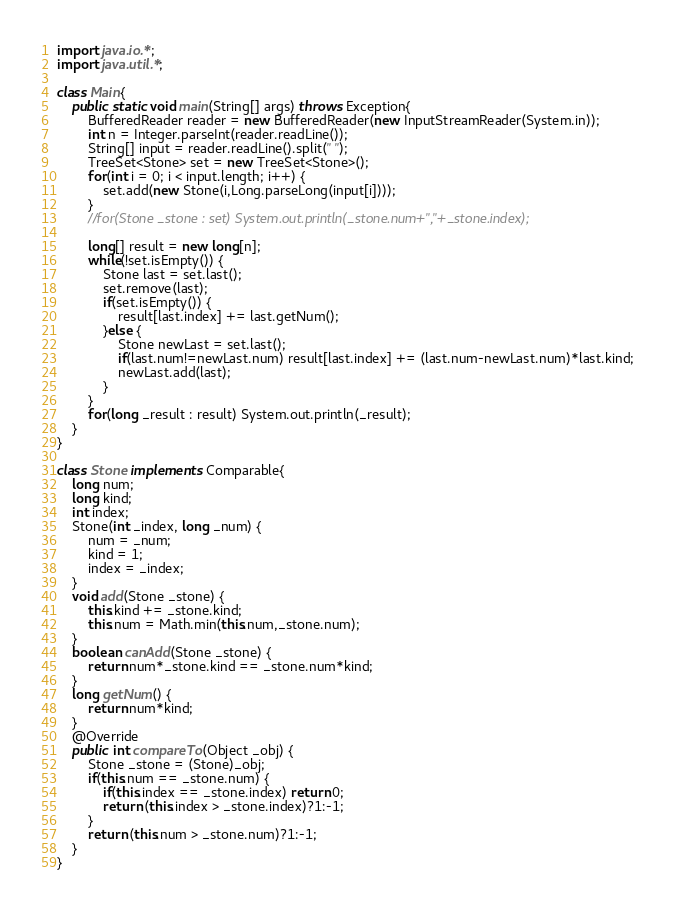<code> <loc_0><loc_0><loc_500><loc_500><_Java_>import java.io.*;
import java.util.*;

class Main{
	public static void main(String[] args) throws Exception{
		BufferedReader reader = new BufferedReader(new InputStreamReader(System.in));
		int n = Integer.parseInt(reader.readLine());
		String[] input = reader.readLine().split(" ");
		TreeSet<Stone> set = new TreeSet<Stone>();
		for(int i = 0; i < input.length; i++) {
			set.add(new Stone(i,Long.parseLong(input[i])));
		}
		//for(Stone _stone : set) System.out.println(_stone.num+","+_stone.index);

		long[] result = new long[n];
		while(!set.isEmpty()) {
			Stone last = set.last();
			set.remove(last);
			if(set.isEmpty()) {
				result[last.index] += last.getNum();
			}else {
				Stone newLast = set.last();
				if(last.num!=newLast.num) result[last.index] += (last.num-newLast.num)*last.kind;
				newLast.add(last);
			}
		}
		for(long _result : result) System.out.println(_result);
	}
}

class Stone implements Comparable{
	long num;
	long kind;
	int index;
	Stone(int _index, long _num) {
		num = _num;
		kind = 1;
		index = _index;
	}
	void add(Stone _stone) {
		this.kind += _stone.kind;
		this.num = Math.min(this.num,_stone.num);
	}
	boolean canAdd(Stone _stone) {
		return num*_stone.kind == _stone.num*kind;
	}
	long getNum() {
		return num*kind;
	}
	@Override
	public int compareTo(Object _obj) {
		Stone _stone = (Stone)_obj;
		if(this.num == _stone.num) {
			if(this.index == _stone.index) return 0;
			return (this.index > _stone.index)?1:-1;
		}
		return (this.num > _stone.num)?1:-1;
	}
}
</code> 